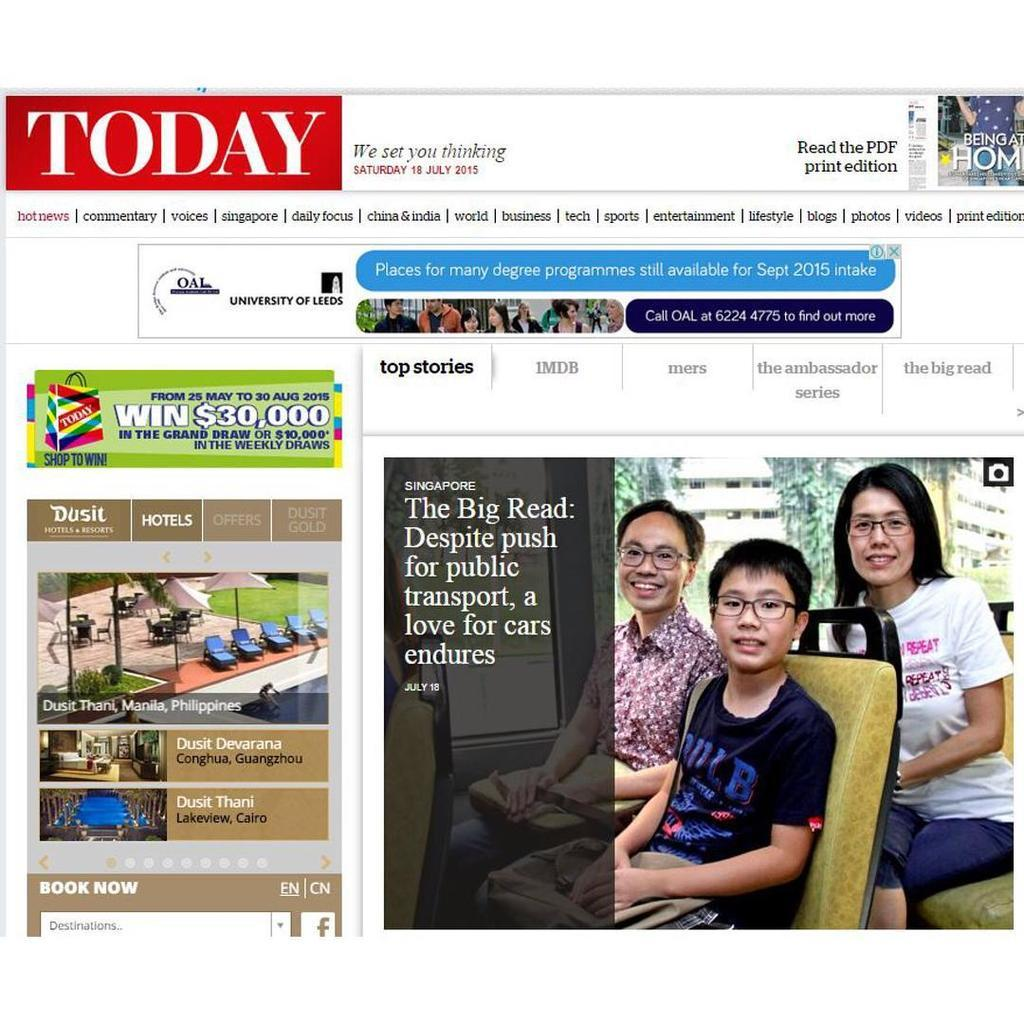<image>
Provide a brief description of the given image. a magazine article with the name Today on it 